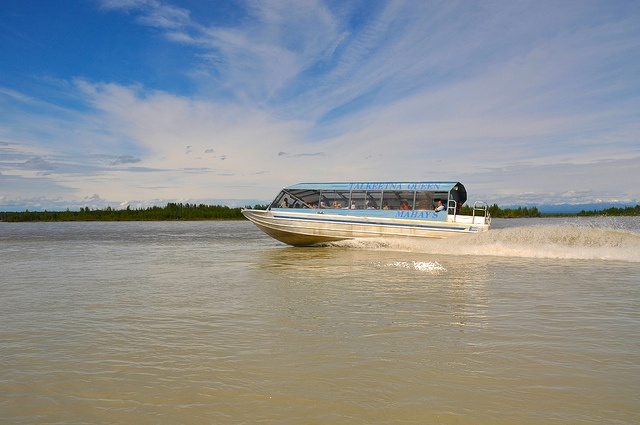Describe the objects in this image and their specific colors. I can see boat in blue, darkgray, gray, tan, and ivory tones, people in blue, black, brown, red, and lightblue tones, people in blue, black, gray, and tan tones, people in blue, gray, and tan tones, and people in blue, gray, darkgray, and black tones in this image. 